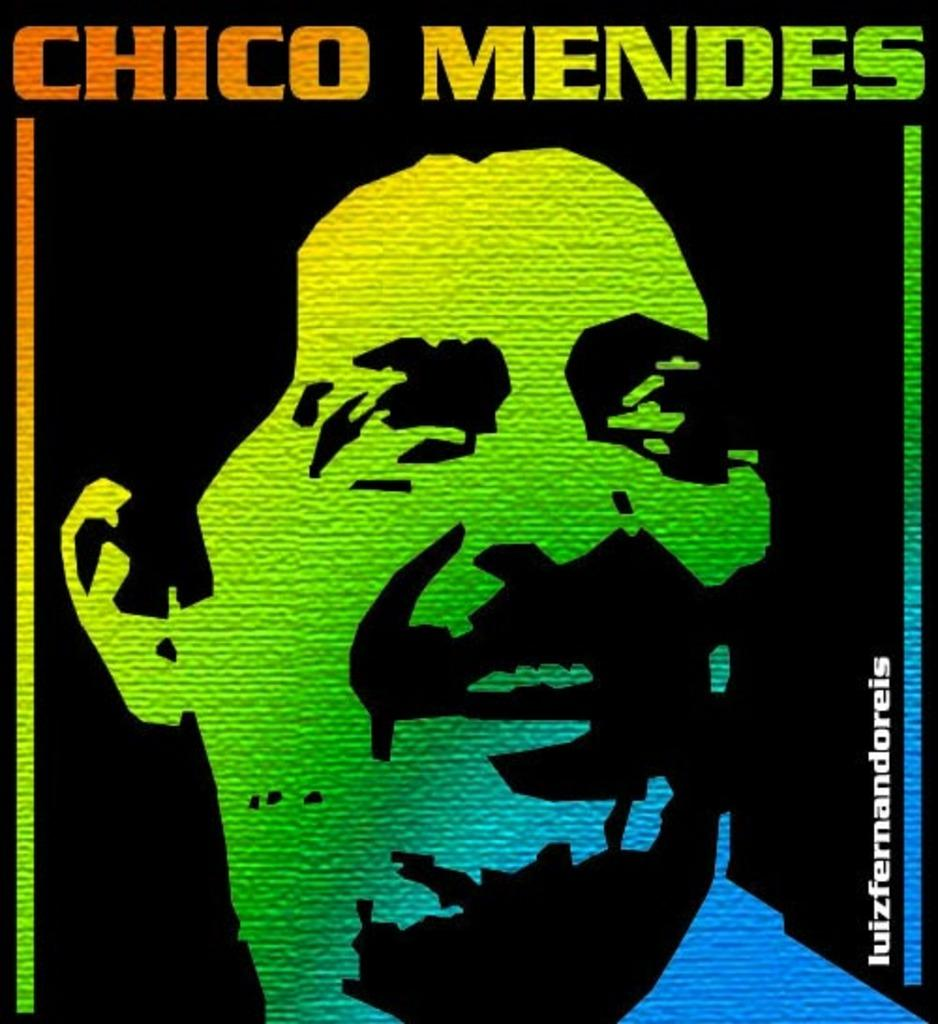<image>
Give a short and clear explanation of the subsequent image. Chico Mendes in shades of yellow, green, and blue. 